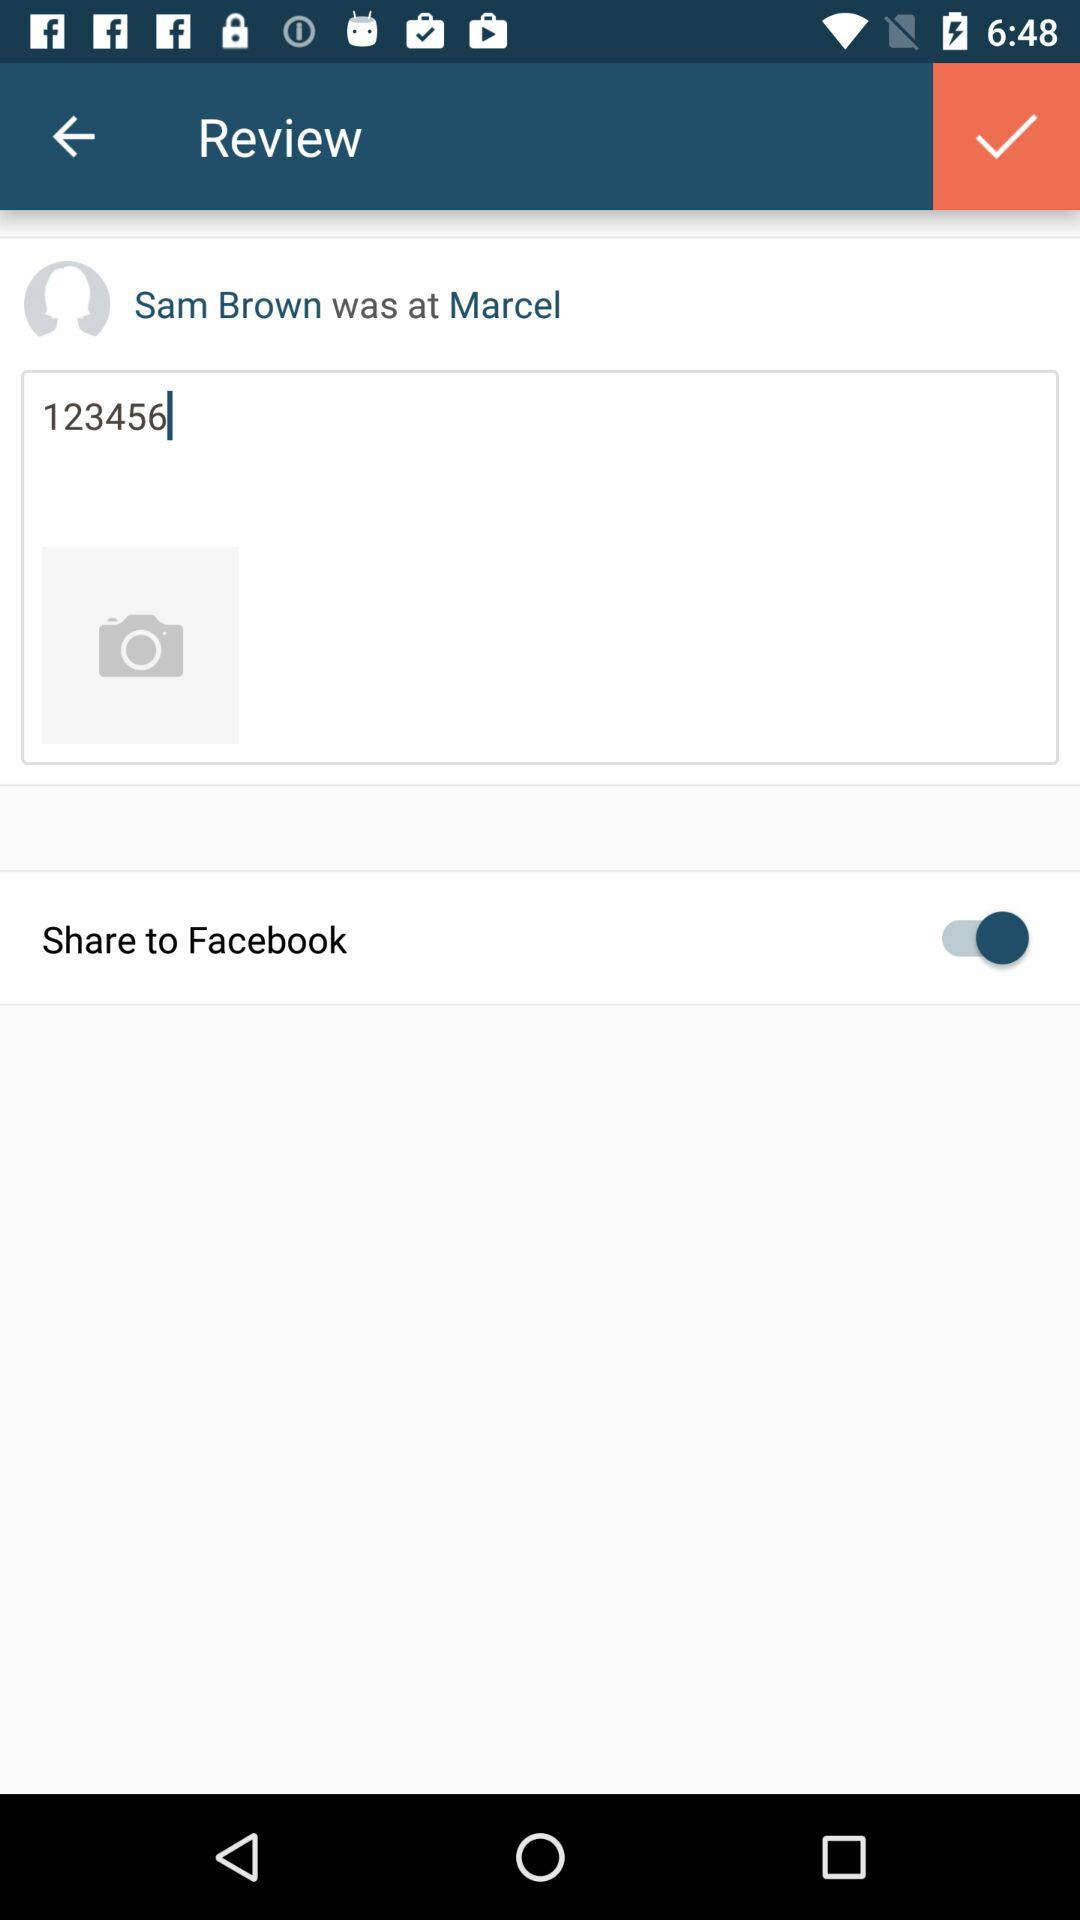What application will the review be shared on? The review will be shared on "Facebook". 